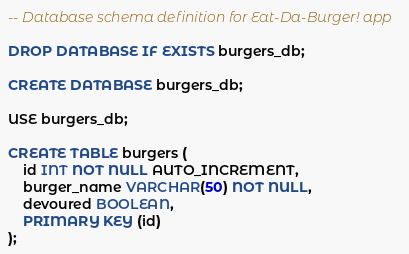Convert code to text. <code><loc_0><loc_0><loc_500><loc_500><_SQL_>-- Database schema definition for Eat-Da-Burger! app

DROP DATABASE IF EXISTS burgers_db;

CREATE DATABASE burgers_db;

USE burgers_db;

CREATE TABLE burgers (
    id INT NOT NULL AUTO_INCREMENT,
    burger_name VARCHAR(50) NOT NULL,
    devoured BOOLEAN,
    PRIMARY KEY (id)
);
</code> 